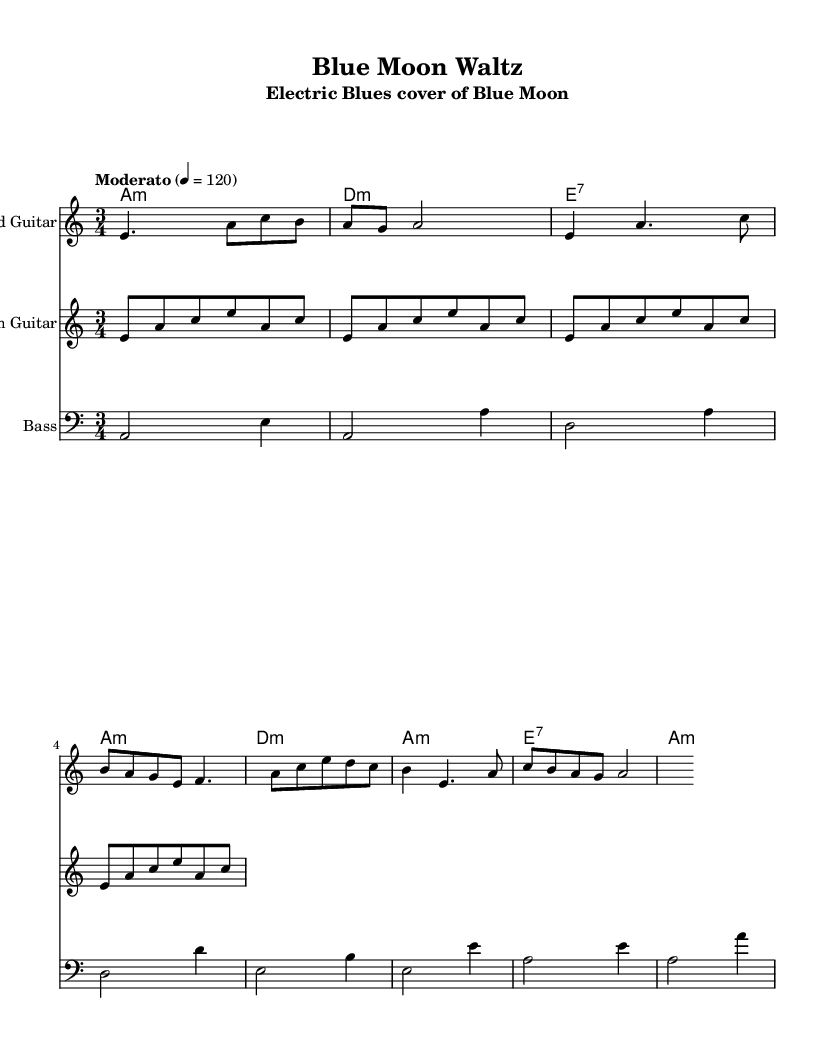What is the key signature of this music? The key signature is A minor, which has no sharps or flats, as shown at the beginning of the score.
Answer: A minor What is the time signature of the piece? The time signature is 3/4, which indicates that there are three beats in each measure, evident from the notation in the score.
Answer: 3/4 What is the tempo marking? The tempo marking indicates "Moderato," which suggests a moderate speed for the performance, noted in the header of the score.
Answer: Moderato How many measures are there in the melody? Counting the individual musical passages, there are eight measures in the melody section of the music.
Answer: Eight Which chord is used in the second measure of harmonies? The second measure indicates a D minor chord, as represented in the chord names under the corresponding measure.
Answer: D minor What is the primary genre of this arrangement? The primary genre of this arrangement is Electric Blues, characterized by the instrumentation and musical style, particularly evident through the use of electric guitar and bass.
Answer: Electric Blues What is the bass clef used for in this piece? The bass clef is used for the bass line, notating lower pitches that typically accompany the harmony and rhythm, indicated at the start of the corresponding staff.
Answer: Bass line 